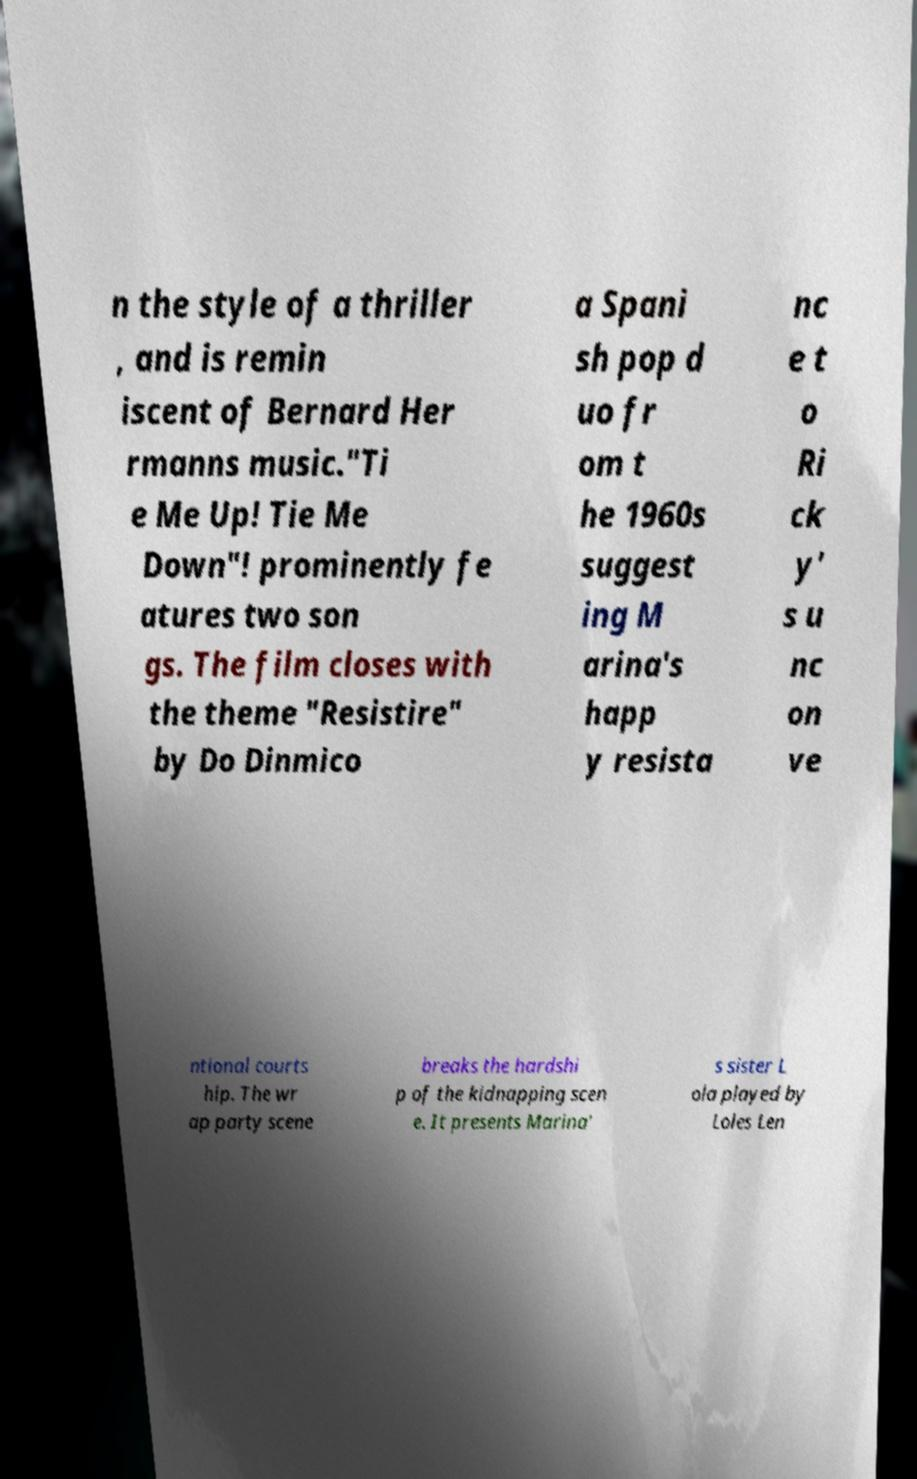Can you accurately transcribe the text from the provided image for me? n the style of a thriller , and is remin iscent of Bernard Her rmanns music."Ti e Me Up! Tie Me Down"! prominently fe atures two son gs. The film closes with the theme "Resistire" by Do Dinmico a Spani sh pop d uo fr om t he 1960s suggest ing M arina's happ y resista nc e t o Ri ck y' s u nc on ve ntional courts hip. The wr ap party scene breaks the hardshi p of the kidnapping scen e. It presents Marina' s sister L ola played by Loles Len 